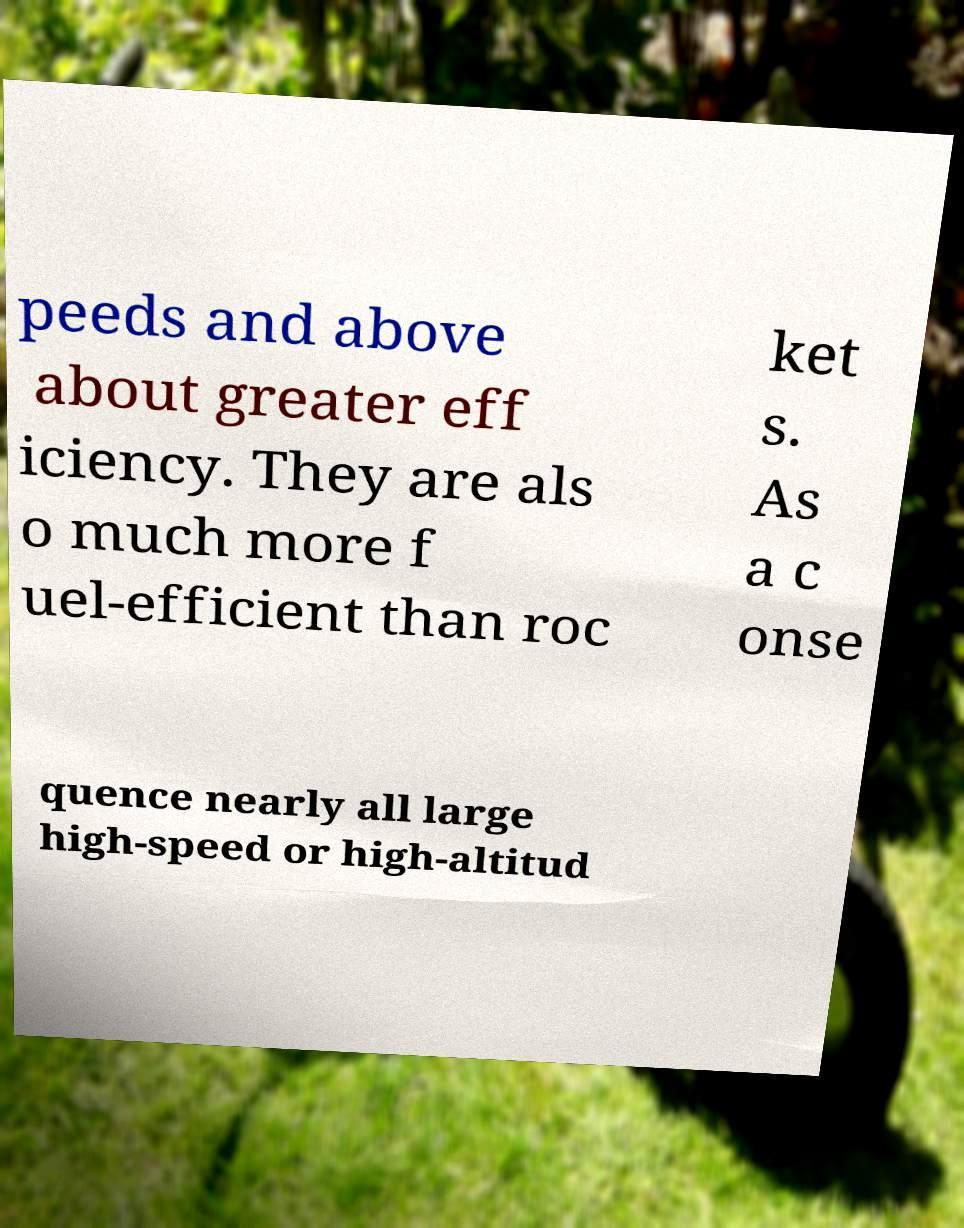Can you accurately transcribe the text from the provided image for me? peeds and above about greater eff iciency. They are als o much more f uel-efficient than roc ket s. As a c onse quence nearly all large high-speed or high-altitud 